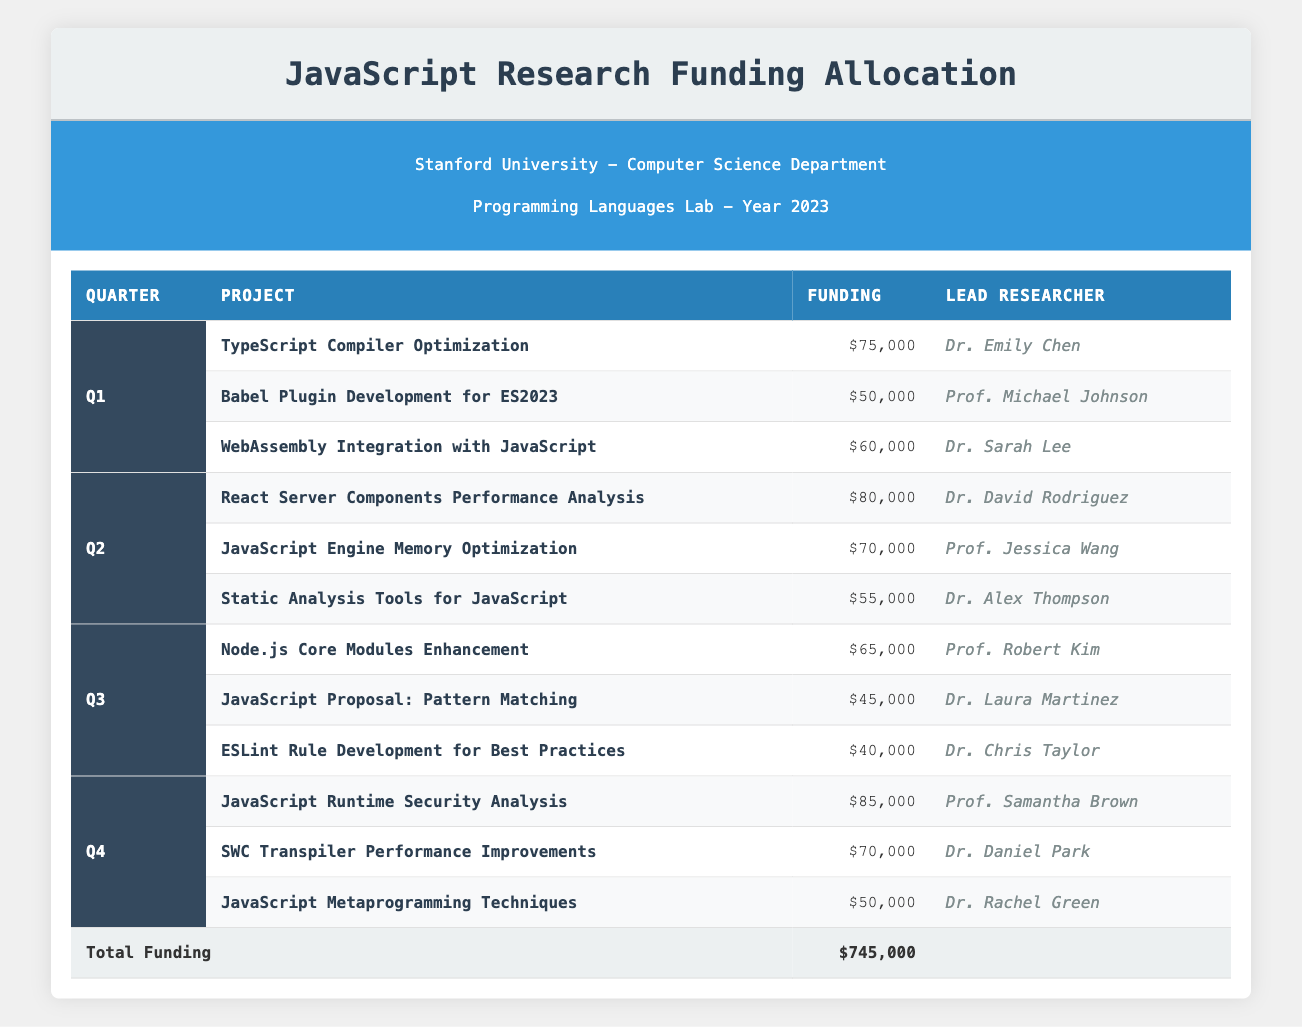What is the total funding allocated for Q1? The total funding for Q1 can be calculated by adding the funding of all projects in that quarter: 75000 + 50000 + 60000 = 185000
Answer: 185000 Who is the lead researcher for the "JavaScript Runtime Security Analysis" project? In the table, the project "JavaScript Runtime Security Analysis" is listed under Q4, with "Prof. Samantha Brown" as the lead researcher
Answer: Prof. Samantha Brown Is the funding for "Static Analysis Tools for JavaScript" higher than that for "JavaScript Proposal: Pattern Matching"? The funding for "Static Analysis Tools for JavaScript" is 55000 and for "JavaScript Proposal: Pattern Matching" is 45000. Since 55000 is greater than 45000, the answer is yes
Answer: Yes What is the average funding for projects in Q2? To find the average funding for Q2, we sum the funding amounts for the three projects: 80000 + 70000 + 55000 = 205000. Then, we divide by the number of projects (3): 205000 / 3 = 68333.33
Answer: Approximately 68333.33 What quarter received the highest funding allocation overall? We need to calculate the total funding for each quarter: Q1: 185000, Q2: 205000, Q3: 150000, Q4: 205000. Both Q2 and Q4 have the highest total of 205000, so we determine they have the same highest allocation
Answer: Q2 and Q4 How much funding was allocated to all projects in 2023? Adding the total funding for each quarter gives the overall total: Q1 (185000) + Q2 (205000) + Q3 (150000) + Q4 (205000) = 745000
Answer: 745000 Did the project "Babel Plugin Development for ES2023" receive more funding than the "Node.js Core Modules Enhancement"? "Babel Plugin Development for ES2023" received 50000 and "Node.js Core Modules Enhancement" received 65000. Since 50000 is less than 65000, the answer is no
Answer: No What is the total number of projects funded in Q3? There are three projects listed under Q3: "Node.js Core Modules Enhancement", "JavaScript Proposal: Pattern Matching", and "ESLint Rule Development for Best Practices", indicating the total is 3
Answer: 3 Which project received the least funding in the entire table? We compare the funding amounts of all projects: 75000, 50000, 60000, 80000, 70000, 55000, 65000, 45000, 40000, 85000, 70000, and 50000. The smallest amount is 40000 from "ESLint Rule Development for Best Practices"
Answer: ESLint Rule Development for Best Practices 